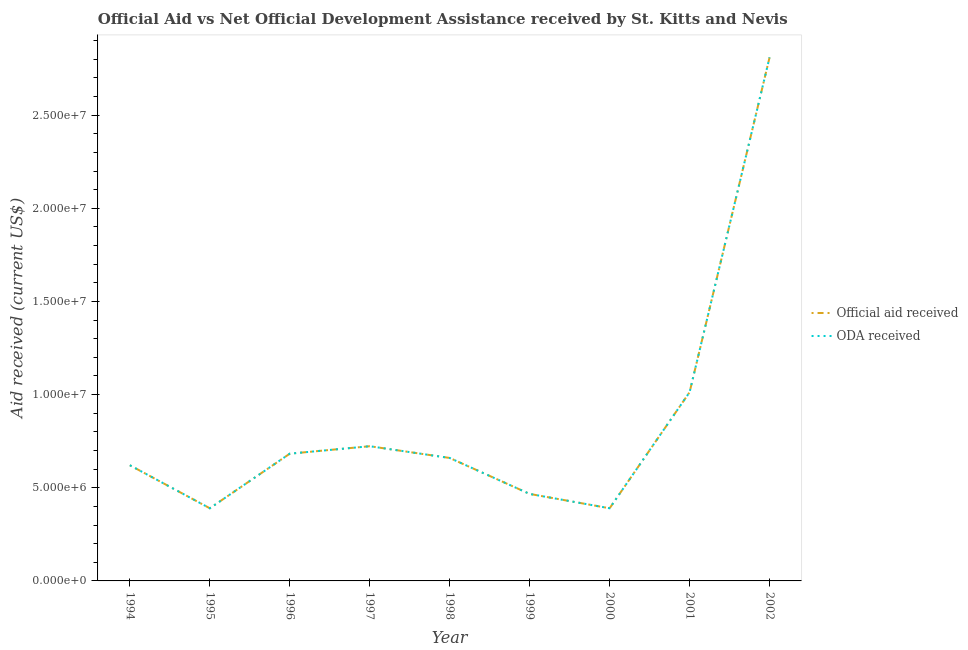How many different coloured lines are there?
Provide a succinct answer. 2. Does the line corresponding to official aid received intersect with the line corresponding to oda received?
Make the answer very short. Yes. What is the official aid received in 1994?
Make the answer very short. 6.21e+06. Across all years, what is the maximum official aid received?
Offer a terse response. 2.81e+07. Across all years, what is the minimum oda received?
Offer a terse response. 3.90e+06. In which year was the oda received maximum?
Provide a short and direct response. 2002. In which year was the oda received minimum?
Your answer should be very brief. 1995. What is the total official aid received in the graph?
Your answer should be compact. 7.76e+07. What is the difference between the oda received in 1996 and that in 2001?
Offer a very short reply. -3.30e+06. What is the difference between the oda received in 2000 and the official aid received in 1996?
Keep it short and to the point. -2.93e+06. What is the average oda received per year?
Offer a terse response. 8.62e+06. In the year 1996, what is the difference between the official aid received and oda received?
Your answer should be compact. 0. In how many years, is the official aid received greater than 28000000 US$?
Your answer should be very brief. 1. What is the ratio of the oda received in 1996 to that in 1999?
Ensure brevity in your answer.  1.46. What is the difference between the highest and the second highest official aid received?
Your answer should be very brief. 1.80e+07. What is the difference between the highest and the lowest oda received?
Offer a very short reply. 2.42e+07. Is the official aid received strictly less than the oda received over the years?
Give a very brief answer. No. How many years are there in the graph?
Provide a short and direct response. 9. What is the difference between two consecutive major ticks on the Y-axis?
Make the answer very short. 5.00e+06. Does the graph contain any zero values?
Ensure brevity in your answer.  No. How many legend labels are there?
Keep it short and to the point. 2. What is the title of the graph?
Keep it short and to the point. Official Aid vs Net Official Development Assistance received by St. Kitts and Nevis . What is the label or title of the X-axis?
Provide a succinct answer. Year. What is the label or title of the Y-axis?
Give a very brief answer. Aid received (current US$). What is the Aid received (current US$) in Official aid received in 1994?
Your answer should be very brief. 6.21e+06. What is the Aid received (current US$) of ODA received in 1994?
Make the answer very short. 6.21e+06. What is the Aid received (current US$) of Official aid received in 1995?
Offer a terse response. 3.90e+06. What is the Aid received (current US$) in ODA received in 1995?
Ensure brevity in your answer.  3.90e+06. What is the Aid received (current US$) in Official aid received in 1996?
Your answer should be compact. 6.83e+06. What is the Aid received (current US$) in ODA received in 1996?
Give a very brief answer. 6.83e+06. What is the Aid received (current US$) in Official aid received in 1997?
Your answer should be compact. 7.23e+06. What is the Aid received (current US$) of ODA received in 1997?
Provide a short and direct response. 7.23e+06. What is the Aid received (current US$) in Official aid received in 1998?
Your answer should be very brief. 6.60e+06. What is the Aid received (current US$) in ODA received in 1998?
Ensure brevity in your answer.  6.60e+06. What is the Aid received (current US$) of Official aid received in 1999?
Make the answer very short. 4.67e+06. What is the Aid received (current US$) in ODA received in 1999?
Give a very brief answer. 4.67e+06. What is the Aid received (current US$) in Official aid received in 2000?
Keep it short and to the point. 3.90e+06. What is the Aid received (current US$) of ODA received in 2000?
Your response must be concise. 3.90e+06. What is the Aid received (current US$) in Official aid received in 2001?
Offer a terse response. 1.01e+07. What is the Aid received (current US$) of ODA received in 2001?
Your response must be concise. 1.01e+07. What is the Aid received (current US$) in Official aid received in 2002?
Offer a terse response. 2.81e+07. What is the Aid received (current US$) in ODA received in 2002?
Give a very brief answer. 2.81e+07. Across all years, what is the maximum Aid received (current US$) of Official aid received?
Offer a terse response. 2.81e+07. Across all years, what is the maximum Aid received (current US$) of ODA received?
Offer a very short reply. 2.81e+07. Across all years, what is the minimum Aid received (current US$) of Official aid received?
Give a very brief answer. 3.90e+06. Across all years, what is the minimum Aid received (current US$) in ODA received?
Offer a very short reply. 3.90e+06. What is the total Aid received (current US$) in Official aid received in the graph?
Provide a short and direct response. 7.76e+07. What is the total Aid received (current US$) of ODA received in the graph?
Make the answer very short. 7.76e+07. What is the difference between the Aid received (current US$) of Official aid received in 1994 and that in 1995?
Ensure brevity in your answer.  2.31e+06. What is the difference between the Aid received (current US$) in ODA received in 1994 and that in 1995?
Offer a terse response. 2.31e+06. What is the difference between the Aid received (current US$) of Official aid received in 1994 and that in 1996?
Provide a short and direct response. -6.20e+05. What is the difference between the Aid received (current US$) in ODA received in 1994 and that in 1996?
Provide a short and direct response. -6.20e+05. What is the difference between the Aid received (current US$) in Official aid received in 1994 and that in 1997?
Your answer should be compact. -1.02e+06. What is the difference between the Aid received (current US$) in ODA received in 1994 and that in 1997?
Ensure brevity in your answer.  -1.02e+06. What is the difference between the Aid received (current US$) in Official aid received in 1994 and that in 1998?
Provide a succinct answer. -3.90e+05. What is the difference between the Aid received (current US$) in ODA received in 1994 and that in 1998?
Provide a short and direct response. -3.90e+05. What is the difference between the Aid received (current US$) in Official aid received in 1994 and that in 1999?
Provide a short and direct response. 1.54e+06. What is the difference between the Aid received (current US$) of ODA received in 1994 and that in 1999?
Make the answer very short. 1.54e+06. What is the difference between the Aid received (current US$) in Official aid received in 1994 and that in 2000?
Ensure brevity in your answer.  2.31e+06. What is the difference between the Aid received (current US$) of ODA received in 1994 and that in 2000?
Provide a succinct answer. 2.31e+06. What is the difference between the Aid received (current US$) of Official aid received in 1994 and that in 2001?
Your answer should be very brief. -3.92e+06. What is the difference between the Aid received (current US$) of ODA received in 1994 and that in 2001?
Make the answer very short. -3.92e+06. What is the difference between the Aid received (current US$) of Official aid received in 1994 and that in 2002?
Provide a succinct answer. -2.19e+07. What is the difference between the Aid received (current US$) of ODA received in 1994 and that in 2002?
Provide a short and direct response. -2.19e+07. What is the difference between the Aid received (current US$) of Official aid received in 1995 and that in 1996?
Make the answer very short. -2.93e+06. What is the difference between the Aid received (current US$) in ODA received in 1995 and that in 1996?
Your answer should be compact. -2.93e+06. What is the difference between the Aid received (current US$) in Official aid received in 1995 and that in 1997?
Offer a terse response. -3.33e+06. What is the difference between the Aid received (current US$) in ODA received in 1995 and that in 1997?
Your response must be concise. -3.33e+06. What is the difference between the Aid received (current US$) in Official aid received in 1995 and that in 1998?
Offer a terse response. -2.70e+06. What is the difference between the Aid received (current US$) of ODA received in 1995 and that in 1998?
Make the answer very short. -2.70e+06. What is the difference between the Aid received (current US$) of Official aid received in 1995 and that in 1999?
Your answer should be very brief. -7.70e+05. What is the difference between the Aid received (current US$) in ODA received in 1995 and that in 1999?
Your answer should be very brief. -7.70e+05. What is the difference between the Aid received (current US$) of Official aid received in 1995 and that in 2001?
Ensure brevity in your answer.  -6.23e+06. What is the difference between the Aid received (current US$) of ODA received in 1995 and that in 2001?
Keep it short and to the point. -6.23e+06. What is the difference between the Aid received (current US$) in Official aid received in 1995 and that in 2002?
Offer a terse response. -2.42e+07. What is the difference between the Aid received (current US$) of ODA received in 1995 and that in 2002?
Provide a succinct answer. -2.42e+07. What is the difference between the Aid received (current US$) of Official aid received in 1996 and that in 1997?
Give a very brief answer. -4.00e+05. What is the difference between the Aid received (current US$) in ODA received in 1996 and that in 1997?
Your response must be concise. -4.00e+05. What is the difference between the Aid received (current US$) in ODA received in 1996 and that in 1998?
Ensure brevity in your answer.  2.30e+05. What is the difference between the Aid received (current US$) of Official aid received in 1996 and that in 1999?
Give a very brief answer. 2.16e+06. What is the difference between the Aid received (current US$) of ODA received in 1996 and that in 1999?
Offer a terse response. 2.16e+06. What is the difference between the Aid received (current US$) in Official aid received in 1996 and that in 2000?
Offer a terse response. 2.93e+06. What is the difference between the Aid received (current US$) of ODA received in 1996 and that in 2000?
Your answer should be very brief. 2.93e+06. What is the difference between the Aid received (current US$) in Official aid received in 1996 and that in 2001?
Your response must be concise. -3.30e+06. What is the difference between the Aid received (current US$) in ODA received in 1996 and that in 2001?
Your answer should be compact. -3.30e+06. What is the difference between the Aid received (current US$) of Official aid received in 1996 and that in 2002?
Make the answer very short. -2.13e+07. What is the difference between the Aid received (current US$) of ODA received in 1996 and that in 2002?
Give a very brief answer. -2.13e+07. What is the difference between the Aid received (current US$) in Official aid received in 1997 and that in 1998?
Offer a terse response. 6.30e+05. What is the difference between the Aid received (current US$) of ODA received in 1997 and that in 1998?
Keep it short and to the point. 6.30e+05. What is the difference between the Aid received (current US$) in Official aid received in 1997 and that in 1999?
Ensure brevity in your answer.  2.56e+06. What is the difference between the Aid received (current US$) of ODA received in 1997 and that in 1999?
Your response must be concise. 2.56e+06. What is the difference between the Aid received (current US$) of Official aid received in 1997 and that in 2000?
Provide a succinct answer. 3.33e+06. What is the difference between the Aid received (current US$) in ODA received in 1997 and that in 2000?
Make the answer very short. 3.33e+06. What is the difference between the Aid received (current US$) of Official aid received in 1997 and that in 2001?
Offer a very short reply. -2.90e+06. What is the difference between the Aid received (current US$) in ODA received in 1997 and that in 2001?
Give a very brief answer. -2.90e+06. What is the difference between the Aid received (current US$) in Official aid received in 1997 and that in 2002?
Offer a very short reply. -2.09e+07. What is the difference between the Aid received (current US$) of ODA received in 1997 and that in 2002?
Give a very brief answer. -2.09e+07. What is the difference between the Aid received (current US$) of Official aid received in 1998 and that in 1999?
Provide a short and direct response. 1.93e+06. What is the difference between the Aid received (current US$) in ODA received in 1998 and that in 1999?
Your response must be concise. 1.93e+06. What is the difference between the Aid received (current US$) of Official aid received in 1998 and that in 2000?
Keep it short and to the point. 2.70e+06. What is the difference between the Aid received (current US$) of ODA received in 1998 and that in 2000?
Provide a short and direct response. 2.70e+06. What is the difference between the Aid received (current US$) of Official aid received in 1998 and that in 2001?
Keep it short and to the point. -3.53e+06. What is the difference between the Aid received (current US$) of ODA received in 1998 and that in 2001?
Ensure brevity in your answer.  -3.53e+06. What is the difference between the Aid received (current US$) of Official aid received in 1998 and that in 2002?
Offer a very short reply. -2.15e+07. What is the difference between the Aid received (current US$) in ODA received in 1998 and that in 2002?
Provide a succinct answer. -2.15e+07. What is the difference between the Aid received (current US$) of Official aid received in 1999 and that in 2000?
Provide a short and direct response. 7.70e+05. What is the difference between the Aid received (current US$) in ODA received in 1999 and that in 2000?
Give a very brief answer. 7.70e+05. What is the difference between the Aid received (current US$) in Official aid received in 1999 and that in 2001?
Ensure brevity in your answer.  -5.46e+06. What is the difference between the Aid received (current US$) in ODA received in 1999 and that in 2001?
Provide a succinct answer. -5.46e+06. What is the difference between the Aid received (current US$) in Official aid received in 1999 and that in 2002?
Provide a short and direct response. -2.34e+07. What is the difference between the Aid received (current US$) of ODA received in 1999 and that in 2002?
Provide a short and direct response. -2.34e+07. What is the difference between the Aid received (current US$) in Official aid received in 2000 and that in 2001?
Provide a short and direct response. -6.23e+06. What is the difference between the Aid received (current US$) in ODA received in 2000 and that in 2001?
Give a very brief answer. -6.23e+06. What is the difference between the Aid received (current US$) of Official aid received in 2000 and that in 2002?
Offer a terse response. -2.42e+07. What is the difference between the Aid received (current US$) of ODA received in 2000 and that in 2002?
Your response must be concise. -2.42e+07. What is the difference between the Aid received (current US$) in Official aid received in 2001 and that in 2002?
Offer a terse response. -1.80e+07. What is the difference between the Aid received (current US$) of ODA received in 2001 and that in 2002?
Keep it short and to the point. -1.80e+07. What is the difference between the Aid received (current US$) of Official aid received in 1994 and the Aid received (current US$) of ODA received in 1995?
Make the answer very short. 2.31e+06. What is the difference between the Aid received (current US$) in Official aid received in 1994 and the Aid received (current US$) in ODA received in 1996?
Keep it short and to the point. -6.20e+05. What is the difference between the Aid received (current US$) of Official aid received in 1994 and the Aid received (current US$) of ODA received in 1997?
Your answer should be very brief. -1.02e+06. What is the difference between the Aid received (current US$) of Official aid received in 1994 and the Aid received (current US$) of ODA received in 1998?
Provide a succinct answer. -3.90e+05. What is the difference between the Aid received (current US$) in Official aid received in 1994 and the Aid received (current US$) in ODA received in 1999?
Your answer should be very brief. 1.54e+06. What is the difference between the Aid received (current US$) of Official aid received in 1994 and the Aid received (current US$) of ODA received in 2000?
Your answer should be very brief. 2.31e+06. What is the difference between the Aid received (current US$) in Official aid received in 1994 and the Aid received (current US$) in ODA received in 2001?
Keep it short and to the point. -3.92e+06. What is the difference between the Aid received (current US$) in Official aid received in 1994 and the Aid received (current US$) in ODA received in 2002?
Your answer should be very brief. -2.19e+07. What is the difference between the Aid received (current US$) of Official aid received in 1995 and the Aid received (current US$) of ODA received in 1996?
Make the answer very short. -2.93e+06. What is the difference between the Aid received (current US$) in Official aid received in 1995 and the Aid received (current US$) in ODA received in 1997?
Make the answer very short. -3.33e+06. What is the difference between the Aid received (current US$) in Official aid received in 1995 and the Aid received (current US$) in ODA received in 1998?
Give a very brief answer. -2.70e+06. What is the difference between the Aid received (current US$) of Official aid received in 1995 and the Aid received (current US$) of ODA received in 1999?
Ensure brevity in your answer.  -7.70e+05. What is the difference between the Aid received (current US$) of Official aid received in 1995 and the Aid received (current US$) of ODA received in 2001?
Provide a succinct answer. -6.23e+06. What is the difference between the Aid received (current US$) of Official aid received in 1995 and the Aid received (current US$) of ODA received in 2002?
Give a very brief answer. -2.42e+07. What is the difference between the Aid received (current US$) in Official aid received in 1996 and the Aid received (current US$) in ODA received in 1997?
Your answer should be compact. -4.00e+05. What is the difference between the Aid received (current US$) of Official aid received in 1996 and the Aid received (current US$) of ODA received in 1998?
Offer a terse response. 2.30e+05. What is the difference between the Aid received (current US$) of Official aid received in 1996 and the Aid received (current US$) of ODA received in 1999?
Offer a very short reply. 2.16e+06. What is the difference between the Aid received (current US$) in Official aid received in 1996 and the Aid received (current US$) in ODA received in 2000?
Make the answer very short. 2.93e+06. What is the difference between the Aid received (current US$) in Official aid received in 1996 and the Aid received (current US$) in ODA received in 2001?
Make the answer very short. -3.30e+06. What is the difference between the Aid received (current US$) in Official aid received in 1996 and the Aid received (current US$) in ODA received in 2002?
Your answer should be very brief. -2.13e+07. What is the difference between the Aid received (current US$) of Official aid received in 1997 and the Aid received (current US$) of ODA received in 1998?
Give a very brief answer. 6.30e+05. What is the difference between the Aid received (current US$) in Official aid received in 1997 and the Aid received (current US$) in ODA received in 1999?
Your answer should be compact. 2.56e+06. What is the difference between the Aid received (current US$) of Official aid received in 1997 and the Aid received (current US$) of ODA received in 2000?
Provide a succinct answer. 3.33e+06. What is the difference between the Aid received (current US$) of Official aid received in 1997 and the Aid received (current US$) of ODA received in 2001?
Keep it short and to the point. -2.90e+06. What is the difference between the Aid received (current US$) of Official aid received in 1997 and the Aid received (current US$) of ODA received in 2002?
Provide a short and direct response. -2.09e+07. What is the difference between the Aid received (current US$) in Official aid received in 1998 and the Aid received (current US$) in ODA received in 1999?
Ensure brevity in your answer.  1.93e+06. What is the difference between the Aid received (current US$) of Official aid received in 1998 and the Aid received (current US$) of ODA received in 2000?
Provide a succinct answer. 2.70e+06. What is the difference between the Aid received (current US$) of Official aid received in 1998 and the Aid received (current US$) of ODA received in 2001?
Your answer should be compact. -3.53e+06. What is the difference between the Aid received (current US$) in Official aid received in 1998 and the Aid received (current US$) in ODA received in 2002?
Your answer should be compact. -2.15e+07. What is the difference between the Aid received (current US$) of Official aid received in 1999 and the Aid received (current US$) of ODA received in 2000?
Ensure brevity in your answer.  7.70e+05. What is the difference between the Aid received (current US$) in Official aid received in 1999 and the Aid received (current US$) in ODA received in 2001?
Make the answer very short. -5.46e+06. What is the difference between the Aid received (current US$) of Official aid received in 1999 and the Aid received (current US$) of ODA received in 2002?
Make the answer very short. -2.34e+07. What is the difference between the Aid received (current US$) in Official aid received in 2000 and the Aid received (current US$) in ODA received in 2001?
Your answer should be very brief. -6.23e+06. What is the difference between the Aid received (current US$) of Official aid received in 2000 and the Aid received (current US$) of ODA received in 2002?
Your answer should be very brief. -2.42e+07. What is the difference between the Aid received (current US$) of Official aid received in 2001 and the Aid received (current US$) of ODA received in 2002?
Your answer should be compact. -1.80e+07. What is the average Aid received (current US$) in Official aid received per year?
Your answer should be very brief. 8.62e+06. What is the average Aid received (current US$) in ODA received per year?
Give a very brief answer. 8.62e+06. In the year 1994, what is the difference between the Aid received (current US$) of Official aid received and Aid received (current US$) of ODA received?
Provide a short and direct response. 0. In the year 1995, what is the difference between the Aid received (current US$) of Official aid received and Aid received (current US$) of ODA received?
Make the answer very short. 0. In the year 1997, what is the difference between the Aid received (current US$) in Official aid received and Aid received (current US$) in ODA received?
Give a very brief answer. 0. In the year 1998, what is the difference between the Aid received (current US$) in Official aid received and Aid received (current US$) in ODA received?
Your response must be concise. 0. In the year 1999, what is the difference between the Aid received (current US$) in Official aid received and Aid received (current US$) in ODA received?
Keep it short and to the point. 0. In the year 2000, what is the difference between the Aid received (current US$) in Official aid received and Aid received (current US$) in ODA received?
Keep it short and to the point. 0. In the year 2001, what is the difference between the Aid received (current US$) in Official aid received and Aid received (current US$) in ODA received?
Ensure brevity in your answer.  0. In the year 2002, what is the difference between the Aid received (current US$) in Official aid received and Aid received (current US$) in ODA received?
Your response must be concise. 0. What is the ratio of the Aid received (current US$) of Official aid received in 1994 to that in 1995?
Ensure brevity in your answer.  1.59. What is the ratio of the Aid received (current US$) of ODA received in 1994 to that in 1995?
Your response must be concise. 1.59. What is the ratio of the Aid received (current US$) in Official aid received in 1994 to that in 1996?
Make the answer very short. 0.91. What is the ratio of the Aid received (current US$) of ODA received in 1994 to that in 1996?
Give a very brief answer. 0.91. What is the ratio of the Aid received (current US$) of Official aid received in 1994 to that in 1997?
Your answer should be very brief. 0.86. What is the ratio of the Aid received (current US$) of ODA received in 1994 to that in 1997?
Provide a short and direct response. 0.86. What is the ratio of the Aid received (current US$) of Official aid received in 1994 to that in 1998?
Your answer should be very brief. 0.94. What is the ratio of the Aid received (current US$) in ODA received in 1994 to that in 1998?
Your answer should be compact. 0.94. What is the ratio of the Aid received (current US$) in Official aid received in 1994 to that in 1999?
Your answer should be compact. 1.33. What is the ratio of the Aid received (current US$) of ODA received in 1994 to that in 1999?
Your answer should be very brief. 1.33. What is the ratio of the Aid received (current US$) in Official aid received in 1994 to that in 2000?
Your response must be concise. 1.59. What is the ratio of the Aid received (current US$) of ODA received in 1994 to that in 2000?
Make the answer very short. 1.59. What is the ratio of the Aid received (current US$) of Official aid received in 1994 to that in 2001?
Make the answer very short. 0.61. What is the ratio of the Aid received (current US$) in ODA received in 1994 to that in 2001?
Your response must be concise. 0.61. What is the ratio of the Aid received (current US$) of Official aid received in 1994 to that in 2002?
Your answer should be very brief. 0.22. What is the ratio of the Aid received (current US$) in ODA received in 1994 to that in 2002?
Your answer should be very brief. 0.22. What is the ratio of the Aid received (current US$) of Official aid received in 1995 to that in 1996?
Ensure brevity in your answer.  0.57. What is the ratio of the Aid received (current US$) of ODA received in 1995 to that in 1996?
Your answer should be very brief. 0.57. What is the ratio of the Aid received (current US$) of Official aid received in 1995 to that in 1997?
Make the answer very short. 0.54. What is the ratio of the Aid received (current US$) of ODA received in 1995 to that in 1997?
Your response must be concise. 0.54. What is the ratio of the Aid received (current US$) of Official aid received in 1995 to that in 1998?
Provide a short and direct response. 0.59. What is the ratio of the Aid received (current US$) of ODA received in 1995 to that in 1998?
Ensure brevity in your answer.  0.59. What is the ratio of the Aid received (current US$) in Official aid received in 1995 to that in 1999?
Offer a terse response. 0.84. What is the ratio of the Aid received (current US$) in ODA received in 1995 to that in 1999?
Keep it short and to the point. 0.84. What is the ratio of the Aid received (current US$) of ODA received in 1995 to that in 2000?
Provide a succinct answer. 1. What is the ratio of the Aid received (current US$) in Official aid received in 1995 to that in 2001?
Your answer should be compact. 0.39. What is the ratio of the Aid received (current US$) of ODA received in 1995 to that in 2001?
Provide a short and direct response. 0.39. What is the ratio of the Aid received (current US$) of Official aid received in 1995 to that in 2002?
Offer a terse response. 0.14. What is the ratio of the Aid received (current US$) of ODA received in 1995 to that in 2002?
Offer a terse response. 0.14. What is the ratio of the Aid received (current US$) of Official aid received in 1996 to that in 1997?
Your response must be concise. 0.94. What is the ratio of the Aid received (current US$) in ODA received in 1996 to that in 1997?
Provide a succinct answer. 0.94. What is the ratio of the Aid received (current US$) in Official aid received in 1996 to that in 1998?
Ensure brevity in your answer.  1.03. What is the ratio of the Aid received (current US$) in ODA received in 1996 to that in 1998?
Your answer should be compact. 1.03. What is the ratio of the Aid received (current US$) in Official aid received in 1996 to that in 1999?
Provide a succinct answer. 1.46. What is the ratio of the Aid received (current US$) of ODA received in 1996 to that in 1999?
Give a very brief answer. 1.46. What is the ratio of the Aid received (current US$) of Official aid received in 1996 to that in 2000?
Offer a terse response. 1.75. What is the ratio of the Aid received (current US$) of ODA received in 1996 to that in 2000?
Keep it short and to the point. 1.75. What is the ratio of the Aid received (current US$) of Official aid received in 1996 to that in 2001?
Your answer should be compact. 0.67. What is the ratio of the Aid received (current US$) in ODA received in 1996 to that in 2001?
Your answer should be very brief. 0.67. What is the ratio of the Aid received (current US$) of Official aid received in 1996 to that in 2002?
Your response must be concise. 0.24. What is the ratio of the Aid received (current US$) of ODA received in 1996 to that in 2002?
Your response must be concise. 0.24. What is the ratio of the Aid received (current US$) in Official aid received in 1997 to that in 1998?
Your response must be concise. 1.1. What is the ratio of the Aid received (current US$) of ODA received in 1997 to that in 1998?
Offer a terse response. 1.1. What is the ratio of the Aid received (current US$) of Official aid received in 1997 to that in 1999?
Make the answer very short. 1.55. What is the ratio of the Aid received (current US$) of ODA received in 1997 to that in 1999?
Make the answer very short. 1.55. What is the ratio of the Aid received (current US$) of Official aid received in 1997 to that in 2000?
Ensure brevity in your answer.  1.85. What is the ratio of the Aid received (current US$) in ODA received in 1997 to that in 2000?
Provide a short and direct response. 1.85. What is the ratio of the Aid received (current US$) of Official aid received in 1997 to that in 2001?
Keep it short and to the point. 0.71. What is the ratio of the Aid received (current US$) of ODA received in 1997 to that in 2001?
Ensure brevity in your answer.  0.71. What is the ratio of the Aid received (current US$) of Official aid received in 1997 to that in 2002?
Keep it short and to the point. 0.26. What is the ratio of the Aid received (current US$) of ODA received in 1997 to that in 2002?
Offer a terse response. 0.26. What is the ratio of the Aid received (current US$) in Official aid received in 1998 to that in 1999?
Keep it short and to the point. 1.41. What is the ratio of the Aid received (current US$) of ODA received in 1998 to that in 1999?
Your answer should be compact. 1.41. What is the ratio of the Aid received (current US$) in Official aid received in 1998 to that in 2000?
Give a very brief answer. 1.69. What is the ratio of the Aid received (current US$) in ODA received in 1998 to that in 2000?
Provide a short and direct response. 1.69. What is the ratio of the Aid received (current US$) in Official aid received in 1998 to that in 2001?
Ensure brevity in your answer.  0.65. What is the ratio of the Aid received (current US$) of ODA received in 1998 to that in 2001?
Your answer should be compact. 0.65. What is the ratio of the Aid received (current US$) in Official aid received in 1998 to that in 2002?
Your answer should be very brief. 0.23. What is the ratio of the Aid received (current US$) of ODA received in 1998 to that in 2002?
Your response must be concise. 0.23. What is the ratio of the Aid received (current US$) in Official aid received in 1999 to that in 2000?
Your answer should be compact. 1.2. What is the ratio of the Aid received (current US$) in ODA received in 1999 to that in 2000?
Ensure brevity in your answer.  1.2. What is the ratio of the Aid received (current US$) in Official aid received in 1999 to that in 2001?
Your answer should be compact. 0.46. What is the ratio of the Aid received (current US$) in ODA received in 1999 to that in 2001?
Provide a short and direct response. 0.46. What is the ratio of the Aid received (current US$) of Official aid received in 1999 to that in 2002?
Your answer should be very brief. 0.17. What is the ratio of the Aid received (current US$) in ODA received in 1999 to that in 2002?
Ensure brevity in your answer.  0.17. What is the ratio of the Aid received (current US$) of Official aid received in 2000 to that in 2001?
Provide a short and direct response. 0.39. What is the ratio of the Aid received (current US$) in ODA received in 2000 to that in 2001?
Your answer should be compact. 0.39. What is the ratio of the Aid received (current US$) of Official aid received in 2000 to that in 2002?
Offer a very short reply. 0.14. What is the ratio of the Aid received (current US$) in ODA received in 2000 to that in 2002?
Give a very brief answer. 0.14. What is the ratio of the Aid received (current US$) of Official aid received in 2001 to that in 2002?
Keep it short and to the point. 0.36. What is the ratio of the Aid received (current US$) in ODA received in 2001 to that in 2002?
Keep it short and to the point. 0.36. What is the difference between the highest and the second highest Aid received (current US$) of Official aid received?
Provide a short and direct response. 1.80e+07. What is the difference between the highest and the second highest Aid received (current US$) of ODA received?
Give a very brief answer. 1.80e+07. What is the difference between the highest and the lowest Aid received (current US$) of Official aid received?
Provide a succinct answer. 2.42e+07. What is the difference between the highest and the lowest Aid received (current US$) in ODA received?
Offer a terse response. 2.42e+07. 